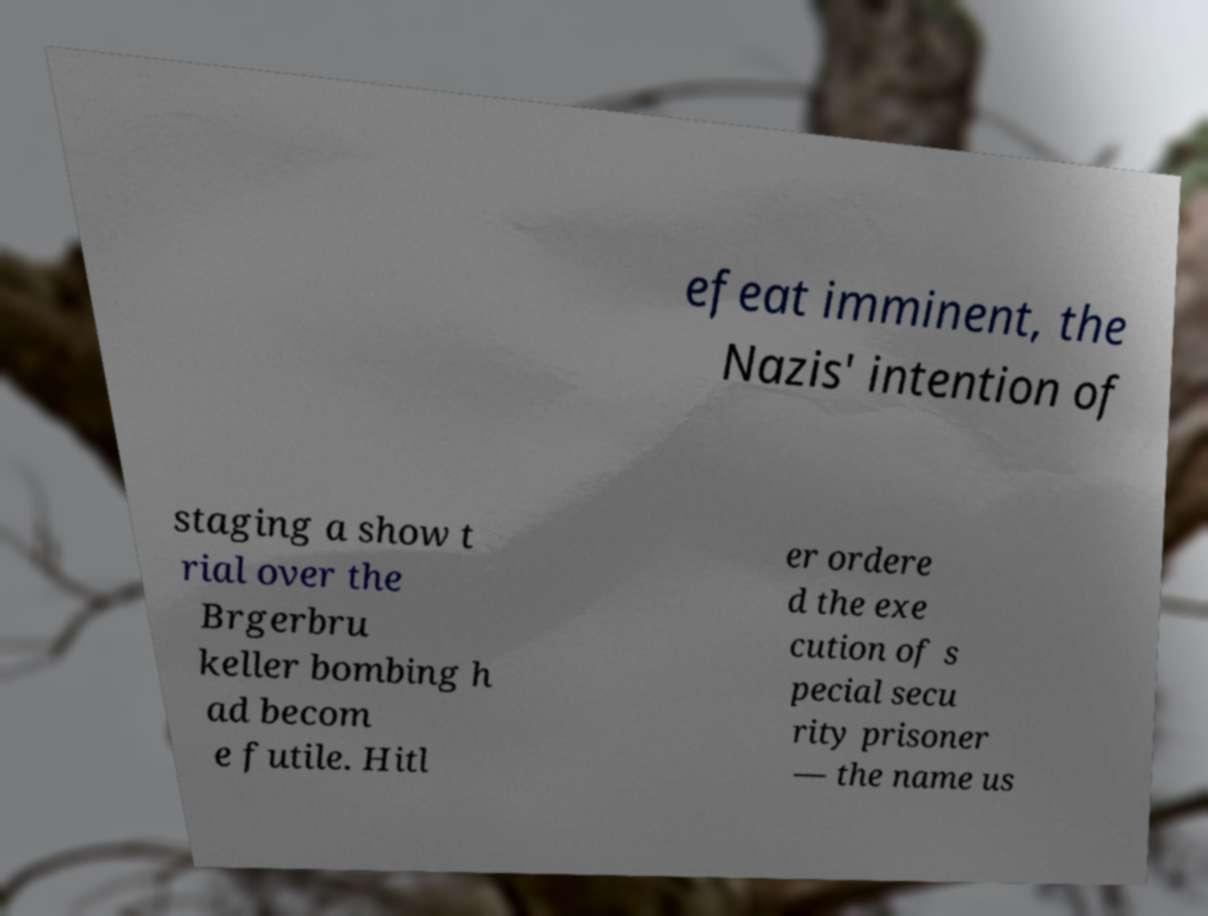Please read and relay the text visible in this image. What does it say? efeat imminent, the Nazis' intention of staging a show t rial over the Brgerbru keller bombing h ad becom e futile. Hitl er ordere d the exe cution of s pecial secu rity prisoner — the name us 